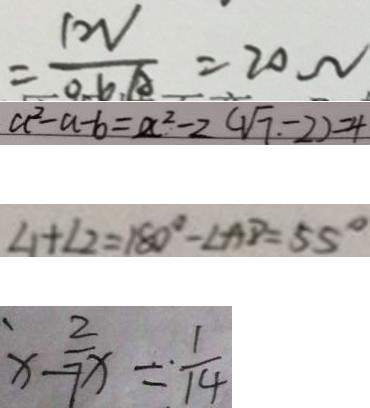Convert formula to latex. <formula><loc_0><loc_0><loc_500><loc_500>= \frac { 1 2 V } { 0 . 6 A } = 2 0 \Omega 
 a ^ { 2 } - a - b = a ^ { 2 } - 2 ( \sqrt { 7 } - 2 ) = 4 
 \angle 1 + \angle 2 = 1 8 0 ^ { \circ } - \angle A D = 5 5 ^ { \circ } 
 x - \frac { 2 } { 7 x } = \frac { 1 } { 1 4 }</formula> 